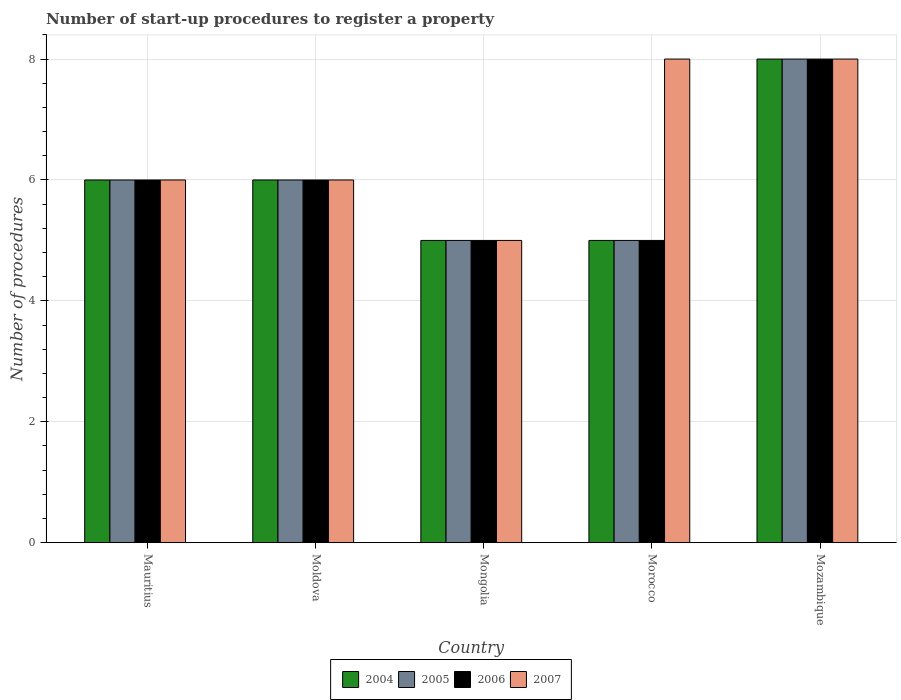How many different coloured bars are there?
Offer a terse response. 4. Are the number of bars on each tick of the X-axis equal?
Ensure brevity in your answer.  Yes. What is the label of the 4th group of bars from the left?
Make the answer very short. Morocco. In how many cases, is the number of bars for a given country not equal to the number of legend labels?
Offer a very short reply. 0. What is the number of procedures required to register a property in 2005 in Morocco?
Keep it short and to the point. 5. Across all countries, what is the maximum number of procedures required to register a property in 2006?
Ensure brevity in your answer.  8. In which country was the number of procedures required to register a property in 2004 maximum?
Keep it short and to the point. Mozambique. In which country was the number of procedures required to register a property in 2005 minimum?
Provide a succinct answer. Mongolia. What is the total number of procedures required to register a property in 2006 in the graph?
Keep it short and to the point. 30. What is the difference between the number of procedures required to register a property in 2004 in Mauritius and that in Mozambique?
Offer a very short reply. -2. What is the difference between the number of procedures required to register a property in 2004 in Morocco and the number of procedures required to register a property in 2005 in Mauritius?
Offer a very short reply. -1. What is the ratio of the number of procedures required to register a property in 2006 in Moldova to that in Mozambique?
Offer a terse response. 0.75. Is the number of procedures required to register a property in 2007 in Mongolia less than that in Morocco?
Give a very brief answer. Yes. Is the difference between the number of procedures required to register a property in 2006 in Mauritius and Morocco greater than the difference between the number of procedures required to register a property in 2005 in Mauritius and Morocco?
Provide a succinct answer. No. What is the difference between the highest and the lowest number of procedures required to register a property in 2004?
Offer a very short reply. 3. In how many countries, is the number of procedures required to register a property in 2005 greater than the average number of procedures required to register a property in 2005 taken over all countries?
Your response must be concise. 1. What does the 2nd bar from the left in Mauritius represents?
Keep it short and to the point. 2005. Is it the case that in every country, the sum of the number of procedures required to register a property in 2007 and number of procedures required to register a property in 2006 is greater than the number of procedures required to register a property in 2005?
Provide a short and direct response. Yes. Are all the bars in the graph horizontal?
Offer a very short reply. No. How many countries are there in the graph?
Provide a succinct answer. 5. What is the difference between two consecutive major ticks on the Y-axis?
Your answer should be very brief. 2. Are the values on the major ticks of Y-axis written in scientific E-notation?
Your answer should be very brief. No. How many legend labels are there?
Make the answer very short. 4. How are the legend labels stacked?
Your response must be concise. Horizontal. What is the title of the graph?
Offer a terse response. Number of start-up procedures to register a property. What is the label or title of the X-axis?
Offer a terse response. Country. What is the label or title of the Y-axis?
Ensure brevity in your answer.  Number of procedures. What is the Number of procedures of 2004 in Mauritius?
Your response must be concise. 6. What is the Number of procedures of 2007 in Mauritius?
Offer a very short reply. 6. What is the Number of procedures in 2004 in Mongolia?
Offer a terse response. 5. What is the Number of procedures of 2005 in Mongolia?
Keep it short and to the point. 5. What is the Number of procedures of 2006 in Mongolia?
Ensure brevity in your answer.  5. What is the Number of procedures of 2007 in Mongolia?
Provide a short and direct response. 5. What is the Number of procedures in 2005 in Morocco?
Provide a short and direct response. 5. What is the Number of procedures of 2006 in Morocco?
Keep it short and to the point. 5. What is the Number of procedures of 2007 in Morocco?
Ensure brevity in your answer.  8. What is the Number of procedures in 2007 in Mozambique?
Ensure brevity in your answer.  8. Across all countries, what is the maximum Number of procedures in 2007?
Offer a terse response. 8. Across all countries, what is the minimum Number of procedures in 2004?
Ensure brevity in your answer.  5. Across all countries, what is the minimum Number of procedures of 2005?
Offer a terse response. 5. What is the total Number of procedures in 2005 in the graph?
Keep it short and to the point. 30. What is the total Number of procedures in 2006 in the graph?
Offer a terse response. 30. What is the difference between the Number of procedures in 2004 in Mauritius and that in Moldova?
Your response must be concise. 0. What is the difference between the Number of procedures of 2005 in Mauritius and that in Moldova?
Provide a short and direct response. 0. What is the difference between the Number of procedures of 2006 in Mauritius and that in Moldova?
Your response must be concise. 0. What is the difference between the Number of procedures in 2004 in Mauritius and that in Mongolia?
Give a very brief answer. 1. What is the difference between the Number of procedures of 2005 in Mauritius and that in Mongolia?
Offer a very short reply. 1. What is the difference between the Number of procedures in 2007 in Mauritius and that in Mongolia?
Give a very brief answer. 1. What is the difference between the Number of procedures of 2006 in Mauritius and that in Morocco?
Keep it short and to the point. 1. What is the difference between the Number of procedures in 2007 in Mauritius and that in Morocco?
Make the answer very short. -2. What is the difference between the Number of procedures of 2005 in Mauritius and that in Mozambique?
Offer a very short reply. -2. What is the difference between the Number of procedures in 2006 in Mauritius and that in Mozambique?
Ensure brevity in your answer.  -2. What is the difference between the Number of procedures in 2007 in Mauritius and that in Mozambique?
Your answer should be compact. -2. What is the difference between the Number of procedures of 2005 in Moldova and that in Mongolia?
Offer a terse response. 1. What is the difference between the Number of procedures in 2007 in Moldova and that in Mongolia?
Your answer should be very brief. 1. What is the difference between the Number of procedures in 2004 in Moldova and that in Morocco?
Offer a very short reply. 1. What is the difference between the Number of procedures of 2005 in Moldova and that in Morocco?
Offer a very short reply. 1. What is the difference between the Number of procedures of 2007 in Moldova and that in Morocco?
Make the answer very short. -2. What is the difference between the Number of procedures in 2004 in Moldova and that in Mozambique?
Your response must be concise. -2. What is the difference between the Number of procedures of 2005 in Moldova and that in Mozambique?
Offer a terse response. -2. What is the difference between the Number of procedures of 2006 in Moldova and that in Mozambique?
Ensure brevity in your answer.  -2. What is the difference between the Number of procedures of 2007 in Moldova and that in Mozambique?
Offer a terse response. -2. What is the difference between the Number of procedures in 2005 in Mongolia and that in Morocco?
Your answer should be very brief. 0. What is the difference between the Number of procedures in 2005 in Morocco and that in Mozambique?
Ensure brevity in your answer.  -3. What is the difference between the Number of procedures of 2007 in Morocco and that in Mozambique?
Your response must be concise. 0. What is the difference between the Number of procedures of 2004 in Mauritius and the Number of procedures of 2006 in Moldova?
Keep it short and to the point. 0. What is the difference between the Number of procedures of 2004 in Mauritius and the Number of procedures of 2007 in Moldova?
Offer a terse response. 0. What is the difference between the Number of procedures of 2005 in Mauritius and the Number of procedures of 2006 in Moldova?
Provide a succinct answer. 0. What is the difference between the Number of procedures of 2005 in Mauritius and the Number of procedures of 2007 in Moldova?
Give a very brief answer. 0. What is the difference between the Number of procedures in 2006 in Mauritius and the Number of procedures in 2007 in Moldova?
Your answer should be very brief. 0. What is the difference between the Number of procedures of 2004 in Mauritius and the Number of procedures of 2005 in Mongolia?
Your answer should be compact. 1. What is the difference between the Number of procedures in 2005 in Mauritius and the Number of procedures in 2007 in Mongolia?
Keep it short and to the point. 1. What is the difference between the Number of procedures of 2006 in Mauritius and the Number of procedures of 2007 in Mongolia?
Your answer should be compact. 1. What is the difference between the Number of procedures of 2004 in Mauritius and the Number of procedures of 2005 in Morocco?
Offer a very short reply. 1. What is the difference between the Number of procedures in 2004 in Mauritius and the Number of procedures in 2007 in Morocco?
Offer a very short reply. -2. What is the difference between the Number of procedures in 2005 in Mauritius and the Number of procedures in 2006 in Morocco?
Provide a short and direct response. 1. What is the difference between the Number of procedures in 2005 in Mauritius and the Number of procedures in 2007 in Morocco?
Offer a terse response. -2. What is the difference between the Number of procedures in 2006 in Mauritius and the Number of procedures in 2007 in Morocco?
Provide a short and direct response. -2. What is the difference between the Number of procedures of 2004 in Mauritius and the Number of procedures of 2007 in Mozambique?
Offer a terse response. -2. What is the difference between the Number of procedures in 2005 in Mauritius and the Number of procedures in 2007 in Mozambique?
Give a very brief answer. -2. What is the difference between the Number of procedures of 2004 in Moldova and the Number of procedures of 2007 in Mongolia?
Your response must be concise. 1. What is the difference between the Number of procedures of 2006 in Moldova and the Number of procedures of 2007 in Mongolia?
Offer a very short reply. 1. What is the difference between the Number of procedures in 2004 in Moldova and the Number of procedures in 2007 in Morocco?
Give a very brief answer. -2. What is the difference between the Number of procedures in 2004 in Moldova and the Number of procedures in 2005 in Mozambique?
Offer a very short reply. -2. What is the difference between the Number of procedures of 2004 in Moldova and the Number of procedures of 2006 in Mozambique?
Keep it short and to the point. -2. What is the difference between the Number of procedures in 2004 in Moldova and the Number of procedures in 2007 in Mozambique?
Offer a terse response. -2. What is the difference between the Number of procedures of 2005 in Moldova and the Number of procedures of 2007 in Mozambique?
Provide a short and direct response. -2. What is the difference between the Number of procedures of 2006 in Moldova and the Number of procedures of 2007 in Mozambique?
Your answer should be very brief. -2. What is the difference between the Number of procedures of 2004 in Mongolia and the Number of procedures of 2005 in Morocco?
Offer a terse response. 0. What is the difference between the Number of procedures in 2004 in Mongolia and the Number of procedures in 2006 in Morocco?
Provide a succinct answer. 0. What is the difference between the Number of procedures of 2005 in Mongolia and the Number of procedures of 2006 in Morocco?
Your answer should be very brief. 0. What is the difference between the Number of procedures in 2004 in Mongolia and the Number of procedures in 2005 in Mozambique?
Give a very brief answer. -3. What is the difference between the Number of procedures of 2005 in Mongolia and the Number of procedures of 2007 in Mozambique?
Your answer should be very brief. -3. What is the difference between the Number of procedures in 2004 in Morocco and the Number of procedures in 2005 in Mozambique?
Keep it short and to the point. -3. What is the difference between the Number of procedures of 2004 in Morocco and the Number of procedures of 2007 in Mozambique?
Make the answer very short. -3. What is the difference between the Number of procedures of 2006 in Morocco and the Number of procedures of 2007 in Mozambique?
Offer a very short reply. -3. What is the average Number of procedures in 2004 per country?
Offer a terse response. 6. What is the average Number of procedures of 2005 per country?
Your answer should be very brief. 6. What is the average Number of procedures of 2006 per country?
Make the answer very short. 6. What is the average Number of procedures in 2007 per country?
Keep it short and to the point. 6.6. What is the difference between the Number of procedures in 2004 and Number of procedures in 2005 in Mauritius?
Offer a terse response. 0. What is the difference between the Number of procedures in 2004 and Number of procedures in 2006 in Mauritius?
Offer a terse response. 0. What is the difference between the Number of procedures in 2004 and Number of procedures in 2007 in Mauritius?
Provide a succinct answer. 0. What is the difference between the Number of procedures of 2005 and Number of procedures of 2007 in Mauritius?
Keep it short and to the point. 0. What is the difference between the Number of procedures of 2004 and Number of procedures of 2005 in Moldova?
Ensure brevity in your answer.  0. What is the difference between the Number of procedures of 2004 and Number of procedures of 2006 in Moldova?
Provide a short and direct response. 0. What is the difference between the Number of procedures in 2005 and Number of procedures in 2007 in Moldova?
Your response must be concise. 0. What is the difference between the Number of procedures of 2006 and Number of procedures of 2007 in Moldova?
Keep it short and to the point. 0. What is the difference between the Number of procedures of 2005 and Number of procedures of 2007 in Mongolia?
Provide a short and direct response. 0. What is the difference between the Number of procedures of 2004 and Number of procedures of 2005 in Morocco?
Provide a succinct answer. 0. What is the difference between the Number of procedures of 2004 and Number of procedures of 2006 in Morocco?
Keep it short and to the point. 0. What is the difference between the Number of procedures of 2005 and Number of procedures of 2006 in Morocco?
Keep it short and to the point. 0. What is the difference between the Number of procedures of 2005 and Number of procedures of 2007 in Morocco?
Give a very brief answer. -3. What is the difference between the Number of procedures of 2004 and Number of procedures of 2005 in Mozambique?
Make the answer very short. 0. What is the difference between the Number of procedures of 2004 and Number of procedures of 2007 in Mozambique?
Your response must be concise. 0. What is the ratio of the Number of procedures of 2006 in Mauritius to that in Moldova?
Provide a succinct answer. 1. What is the ratio of the Number of procedures of 2007 in Mauritius to that in Moldova?
Provide a short and direct response. 1. What is the ratio of the Number of procedures in 2004 in Mauritius to that in Mongolia?
Offer a terse response. 1.2. What is the ratio of the Number of procedures in 2007 in Mauritius to that in Mongolia?
Your answer should be very brief. 1.2. What is the ratio of the Number of procedures of 2004 in Mauritius to that in Morocco?
Provide a short and direct response. 1.2. What is the ratio of the Number of procedures in 2005 in Mauritius to that in Morocco?
Keep it short and to the point. 1.2. What is the ratio of the Number of procedures of 2007 in Mauritius to that in Morocco?
Keep it short and to the point. 0.75. What is the ratio of the Number of procedures of 2004 in Mauritius to that in Mozambique?
Offer a terse response. 0.75. What is the ratio of the Number of procedures in 2006 in Mauritius to that in Mozambique?
Your answer should be very brief. 0.75. What is the ratio of the Number of procedures of 2007 in Mauritius to that in Mozambique?
Provide a succinct answer. 0.75. What is the ratio of the Number of procedures in 2004 in Moldova to that in Mongolia?
Provide a succinct answer. 1.2. What is the ratio of the Number of procedures in 2005 in Moldova to that in Mongolia?
Offer a very short reply. 1.2. What is the ratio of the Number of procedures of 2004 in Moldova to that in Morocco?
Provide a succinct answer. 1.2. What is the ratio of the Number of procedures of 2005 in Moldova to that in Morocco?
Your answer should be very brief. 1.2. What is the ratio of the Number of procedures in 2007 in Moldova to that in Morocco?
Your answer should be compact. 0.75. What is the ratio of the Number of procedures of 2006 in Moldova to that in Mozambique?
Offer a terse response. 0.75. What is the ratio of the Number of procedures of 2007 in Moldova to that in Mozambique?
Your answer should be very brief. 0.75. What is the ratio of the Number of procedures of 2005 in Mongolia to that in Morocco?
Provide a short and direct response. 1. What is the ratio of the Number of procedures in 2007 in Mongolia to that in Mozambique?
Provide a succinct answer. 0.62. What is the ratio of the Number of procedures of 2004 in Morocco to that in Mozambique?
Ensure brevity in your answer.  0.62. What is the ratio of the Number of procedures in 2005 in Morocco to that in Mozambique?
Make the answer very short. 0.62. What is the ratio of the Number of procedures in 2007 in Morocco to that in Mozambique?
Make the answer very short. 1. What is the difference between the highest and the second highest Number of procedures in 2005?
Offer a very short reply. 2. What is the difference between the highest and the lowest Number of procedures in 2007?
Offer a terse response. 3. 